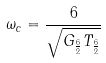<formula> <loc_0><loc_0><loc_500><loc_500>\omega _ { c } = \frac { 6 } { \sqrt { G _ { \frac { 6 } { 2 } } T _ { \frac { 6 } { 2 } } } }</formula> 